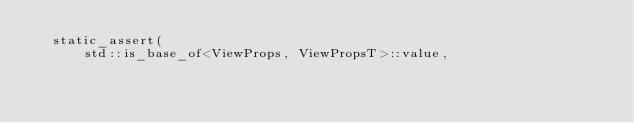Convert code to text. <code><loc_0><loc_0><loc_500><loc_500><_C_>  static_assert(
      std::is_base_of<ViewProps, ViewPropsT>::value,</code> 